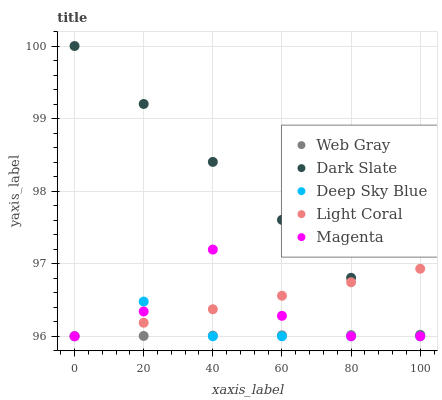Does Web Gray have the minimum area under the curve?
Answer yes or no. Yes. Does Dark Slate have the maximum area under the curve?
Answer yes or no. Yes. Does Magenta have the minimum area under the curve?
Answer yes or no. No. Does Magenta have the maximum area under the curve?
Answer yes or no. No. Is Light Coral the smoothest?
Answer yes or no. Yes. Is Magenta the roughest?
Answer yes or no. Yes. Is Dark Slate the smoothest?
Answer yes or no. No. Is Dark Slate the roughest?
Answer yes or no. No. Does Light Coral have the lowest value?
Answer yes or no. Yes. Does Dark Slate have the lowest value?
Answer yes or no. No. Does Dark Slate have the highest value?
Answer yes or no. Yes. Does Magenta have the highest value?
Answer yes or no. No. Is Deep Sky Blue less than Dark Slate?
Answer yes or no. Yes. Is Dark Slate greater than Deep Sky Blue?
Answer yes or no. Yes. Does Light Coral intersect Magenta?
Answer yes or no. Yes. Is Light Coral less than Magenta?
Answer yes or no. No. Is Light Coral greater than Magenta?
Answer yes or no. No. Does Deep Sky Blue intersect Dark Slate?
Answer yes or no. No. 